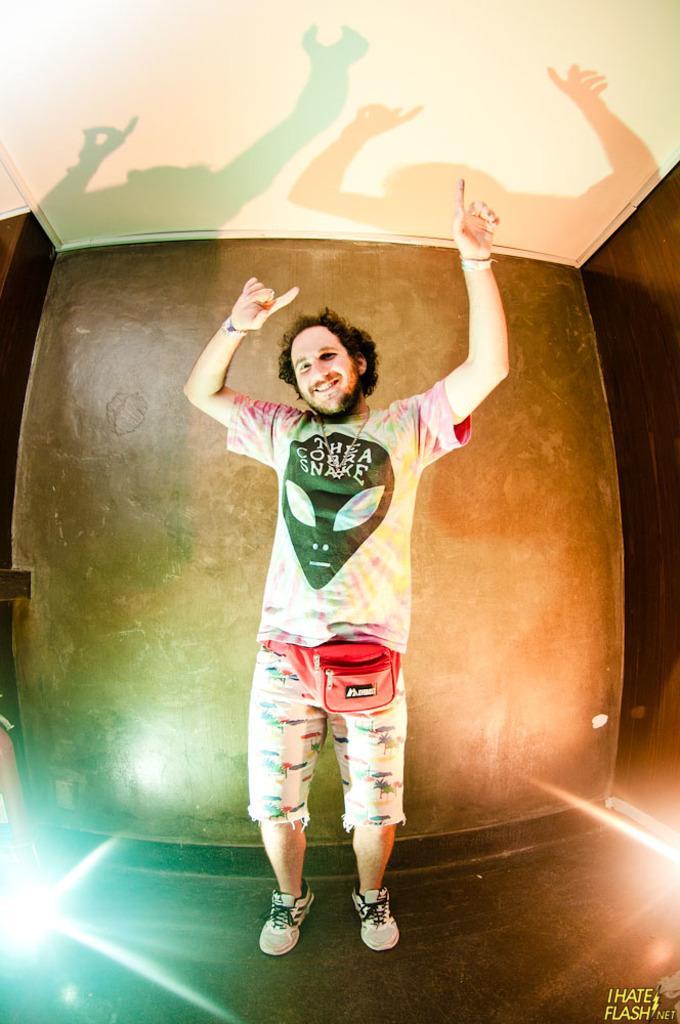Could you give a brief overview of what you see in this image? In this image there is a person dancing on the floor, behind him there is a wall. At the top of the image there is a ceiling. 